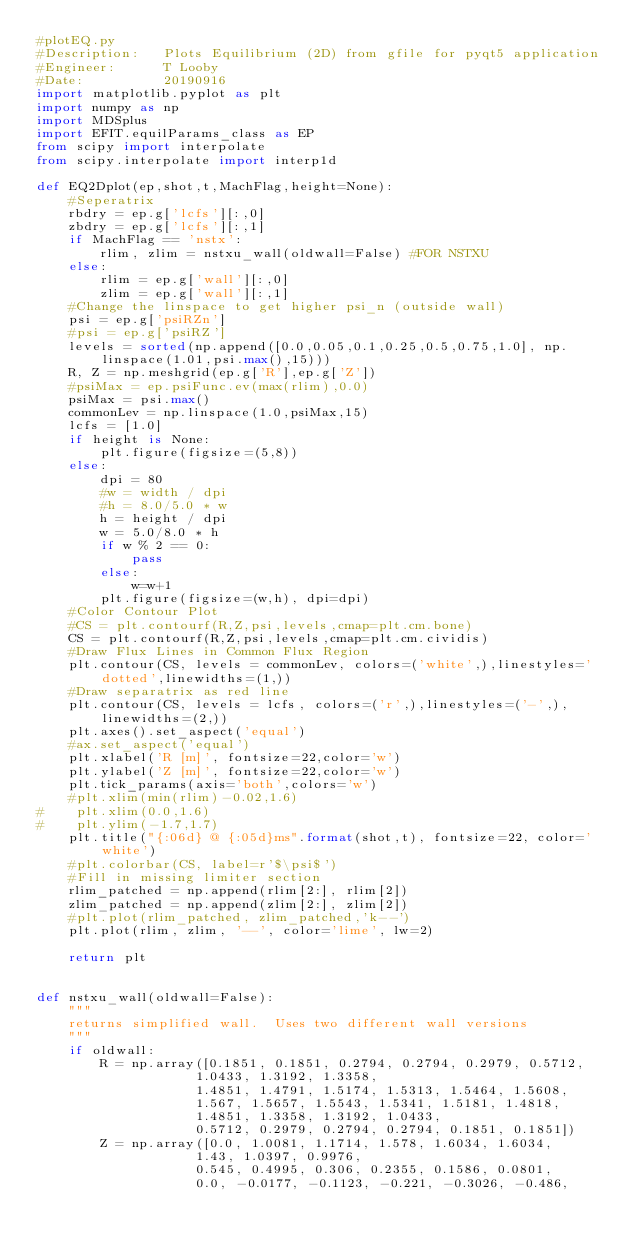<code> <loc_0><loc_0><loc_500><loc_500><_Python_>#plotEQ.py
#Description:   Plots Equilibrium (2D) from gfile for pyqt5 application
#Engineer:      T Looby
#Date:          20190916
import matplotlib.pyplot as plt
import numpy as np
import MDSplus
import EFIT.equilParams_class as EP
from scipy import interpolate
from scipy.interpolate import interp1d

def EQ2Dplot(ep,shot,t,MachFlag,height=None):
    #Seperatrix
    rbdry = ep.g['lcfs'][:,0]
    zbdry = ep.g['lcfs'][:,1]
    if MachFlag == 'nstx':
        rlim, zlim = nstxu_wall(oldwall=False) #FOR NSTXU
    else:
        rlim = ep.g['wall'][:,0]
        zlim = ep.g['wall'][:,1]
    #Change the linspace to get higher psi_n (outside wall)
    psi = ep.g['psiRZn']
    #psi = ep.g['psiRZ']
    levels = sorted(np.append([0.0,0.05,0.1,0.25,0.5,0.75,1.0], np.linspace(1.01,psi.max(),15)))
    R, Z = np.meshgrid(ep.g['R'],ep.g['Z'])
    #psiMax = ep.psiFunc.ev(max(rlim),0.0)
    psiMax = psi.max()
    commonLev = np.linspace(1.0,psiMax,15)
    lcfs = [1.0]
    if height is None:
        plt.figure(figsize=(5,8))
    else:
        dpi = 80
        #w = width / dpi
        #h = 8.0/5.0 * w
        h = height / dpi
        w = 5.0/8.0 * h
        if w % 2 == 0:
            pass
        else:
            w=w+1
        plt.figure(figsize=(w,h), dpi=dpi)
    #Color Contour Plot
    #CS = plt.contourf(R,Z,psi,levels,cmap=plt.cm.bone)
    CS = plt.contourf(R,Z,psi,levels,cmap=plt.cm.cividis)
    #Draw Flux Lines in Common Flux Region
    plt.contour(CS, levels = commonLev, colors=('white',),linestyles='dotted',linewidths=(1,))
    #Draw separatrix as red line
    plt.contour(CS, levels = lcfs, colors=('r',),linestyles=('-',),linewidths=(2,))
    plt.axes().set_aspect('equal')
    #ax.set_aspect('equal')
    plt.xlabel('R [m]', fontsize=22,color='w')
    plt.ylabel('Z [m]', fontsize=22,color='w')
    plt.tick_params(axis='both',colors='w')
    #plt.xlim(min(rlim)-0.02,1.6)
#    plt.xlim(0.0,1.6)
#    plt.ylim(-1.7,1.7)
    plt.title("{:06d} @ {:05d}ms".format(shot,t), fontsize=22, color='white')
    #plt.colorbar(CS, label=r'$\psi$')
    #Fill in missing limiter section
    rlim_patched = np.append(rlim[2:], rlim[2])
    zlim_patched = np.append(zlim[2:], zlim[2])
    #plt.plot(rlim_patched, zlim_patched,'k--')
    plt.plot(rlim, zlim, '--', color='lime', lw=2)

    return plt


def nstxu_wall(oldwall=False):
    """
    returns simplified wall.  Uses two different wall versions
    """
    if oldwall:
        R = np.array([0.1851, 0.1851, 0.2794, 0.2794, 0.2979, 0.5712,
                    1.0433, 1.3192, 1.3358,
                    1.4851, 1.4791, 1.5174, 1.5313, 1.5464, 1.5608,
                    1.567, 1.5657, 1.5543, 1.5341, 1.5181, 1.4818,
                    1.4851, 1.3358, 1.3192, 1.0433,
                    0.5712, 0.2979, 0.2794, 0.2794, 0.1851, 0.1851])
        Z = np.array([0.0, 1.0081, 1.1714, 1.578, 1.6034, 1.6034,
                    1.43, 1.0397, 0.9976,
                    0.545, 0.4995, 0.306, 0.2355, 0.1586, 0.0801,
                    0.0, -0.0177, -0.1123, -0.221, -0.3026, -0.486,</code> 